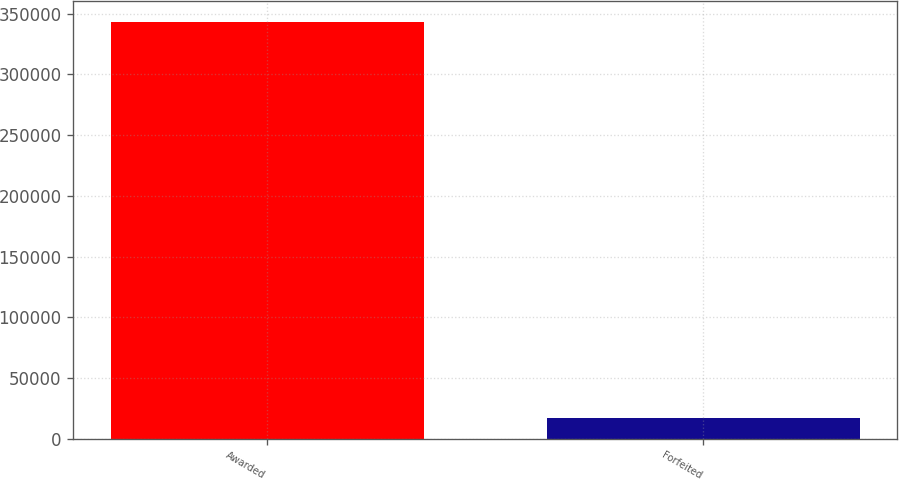Convert chart. <chart><loc_0><loc_0><loc_500><loc_500><bar_chart><fcel>Awarded<fcel>Forfeited<nl><fcel>343500<fcel>17438<nl></chart> 